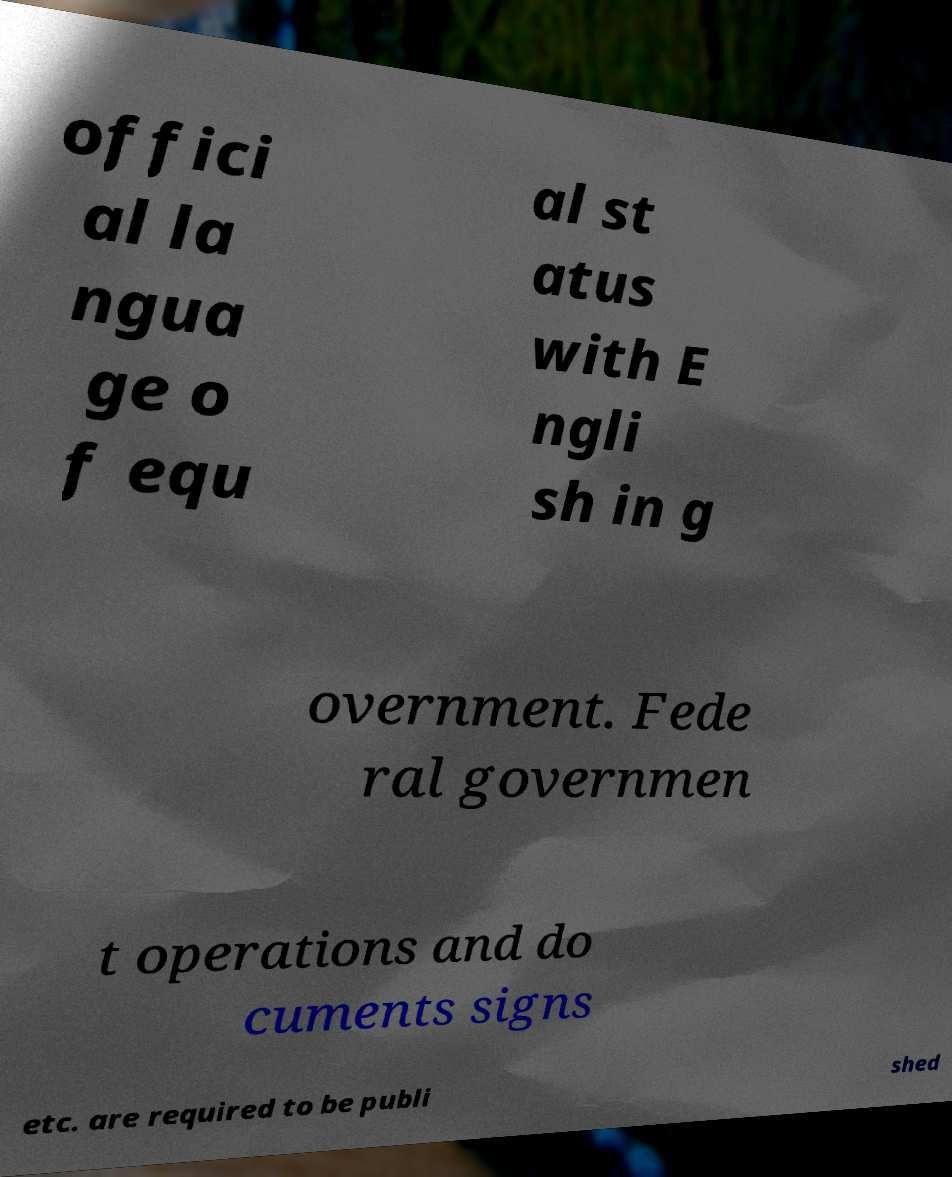Could you extract and type out the text from this image? offici al la ngua ge o f equ al st atus with E ngli sh in g overnment. Fede ral governmen t operations and do cuments signs etc. are required to be publi shed 